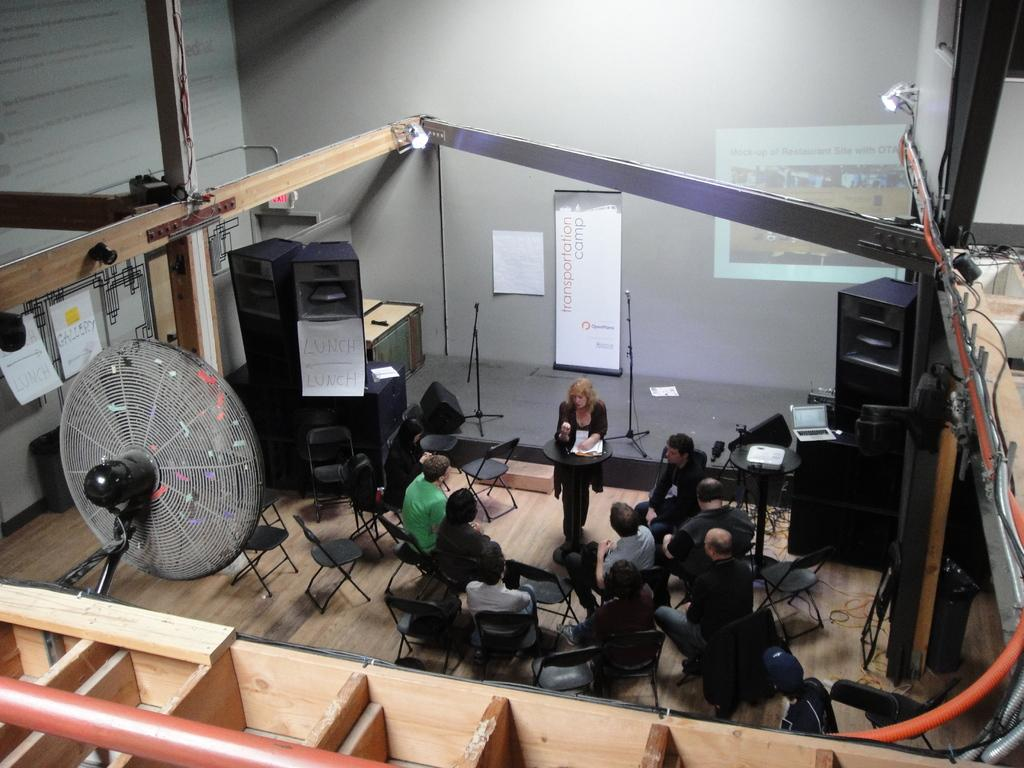What are the people in the image doing? There is a group of people sitting on chairs in the image. What is the woman standing at in the image? The woman is standing at a stand in the image. What can be seen in the image to provide ventilation? There is a fan in the image. What is used for amplifying sound in the image? There are speakers in the image. What type of visual aids are present in the image? There are posters and a banner in the image. What is used for displaying information or visuals in the image? There is a screen in the image. What can be seen in the background of the image? There is a wall in the background of the image. How many zebras are visible in the image? There are no zebras present in the image. What is the back of the screen used for in the image? The back of the screen is not visible in the image, and its purpose cannot be determined. 